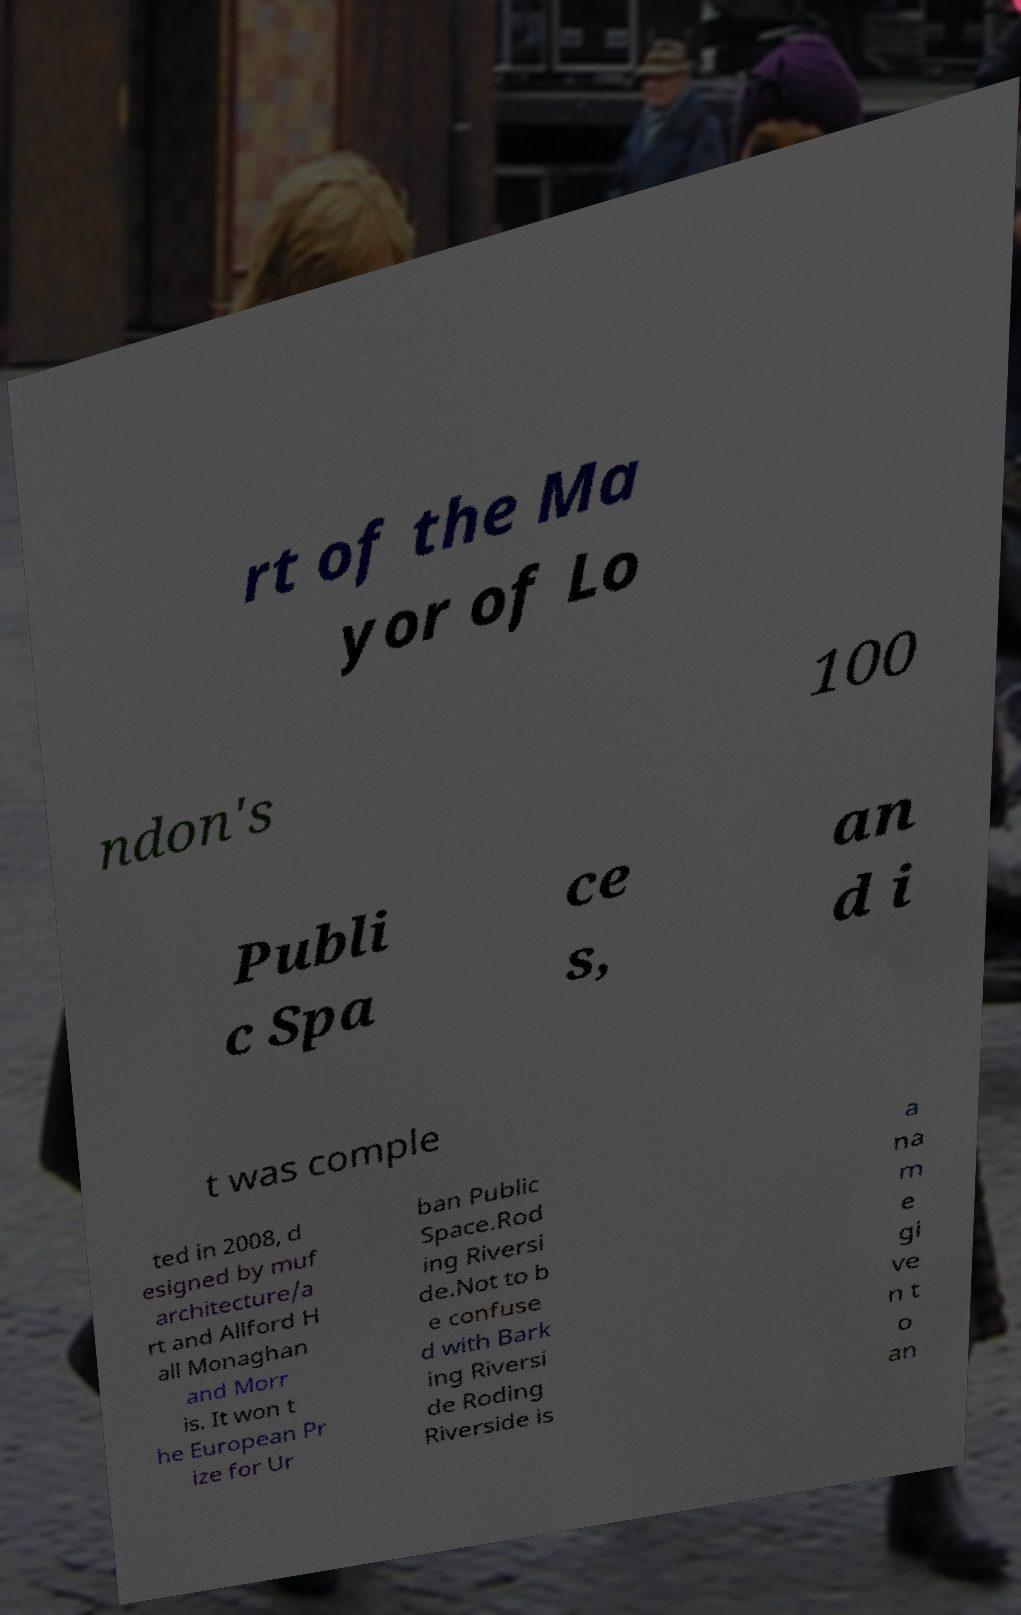Can you read and provide the text displayed in the image?This photo seems to have some interesting text. Can you extract and type it out for me? rt of the Ma yor of Lo ndon's 100 Publi c Spa ce s, an d i t was comple ted in 2008, d esigned by muf architecture/a rt and Allford H all Monaghan and Morr is. It won t he European Pr ize for Ur ban Public Space.Rod ing Riversi de.Not to b e confuse d with Bark ing Riversi de Roding Riverside is a na m e gi ve n t o an 